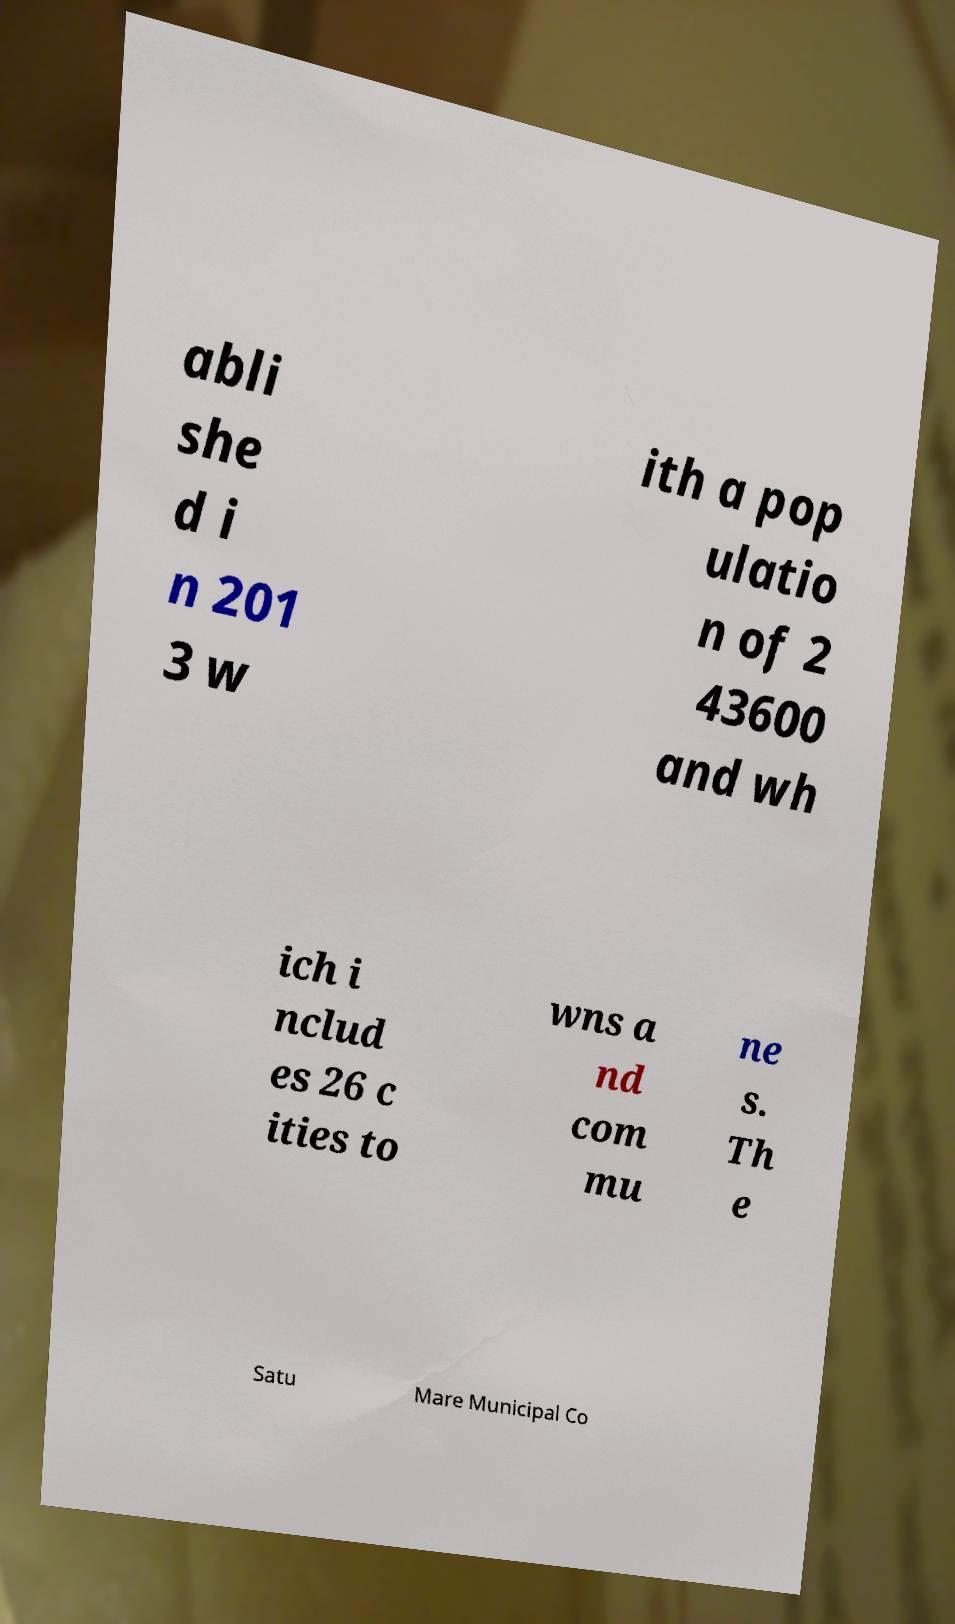Could you assist in decoding the text presented in this image and type it out clearly? abli she d i n 201 3 w ith a pop ulatio n of 2 43600 and wh ich i nclud es 26 c ities to wns a nd com mu ne s. Th e Satu Mare Municipal Co 